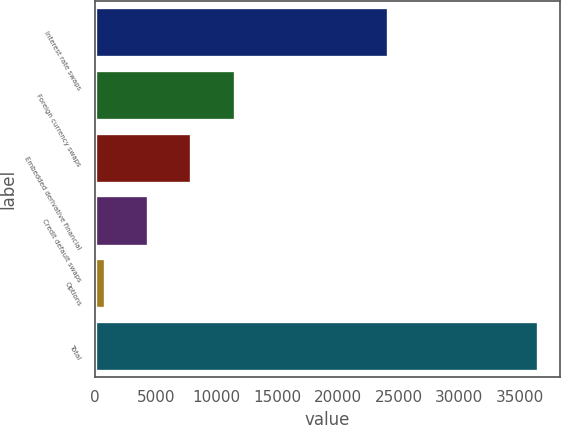<chart> <loc_0><loc_0><loc_500><loc_500><bar_chart><fcel>Interest rate swaps<fcel>Foreign currency swaps<fcel>Embedded derivative financial<fcel>Credit default swaps<fcel>Options<fcel>Total<nl><fcel>24148.6<fcel>11502.9<fcel>7934.4<fcel>4365.95<fcel>797.5<fcel>36482<nl></chart> 